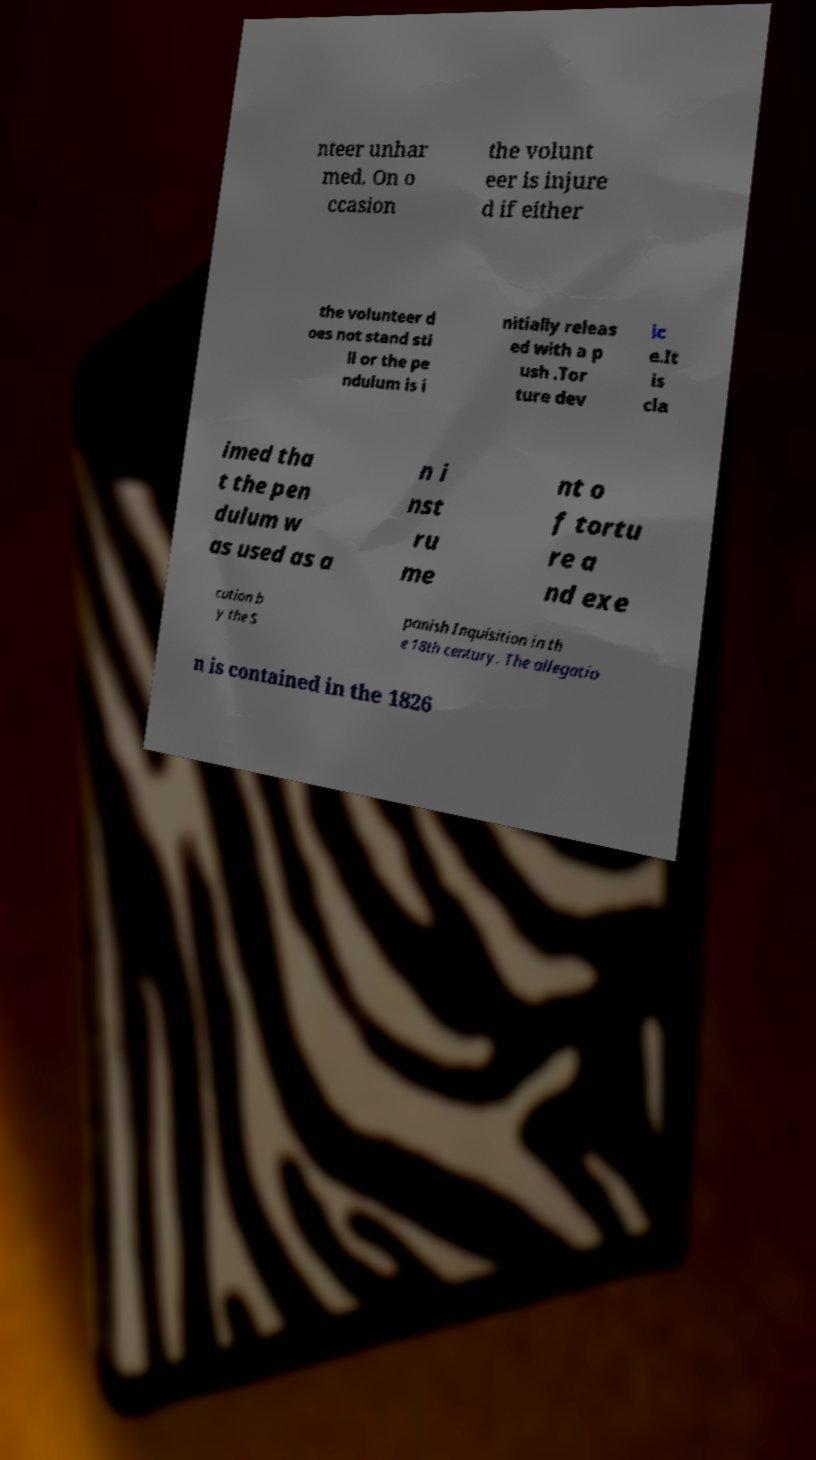For documentation purposes, I need the text within this image transcribed. Could you provide that? nteer unhar med. On o ccasion the volunt eer is injure d if either the volunteer d oes not stand sti ll or the pe ndulum is i nitially releas ed with a p ush .Tor ture dev ic e.It is cla imed tha t the pen dulum w as used as a n i nst ru me nt o f tortu re a nd exe cution b y the S panish Inquisition in th e 18th century. The allegatio n is contained in the 1826 